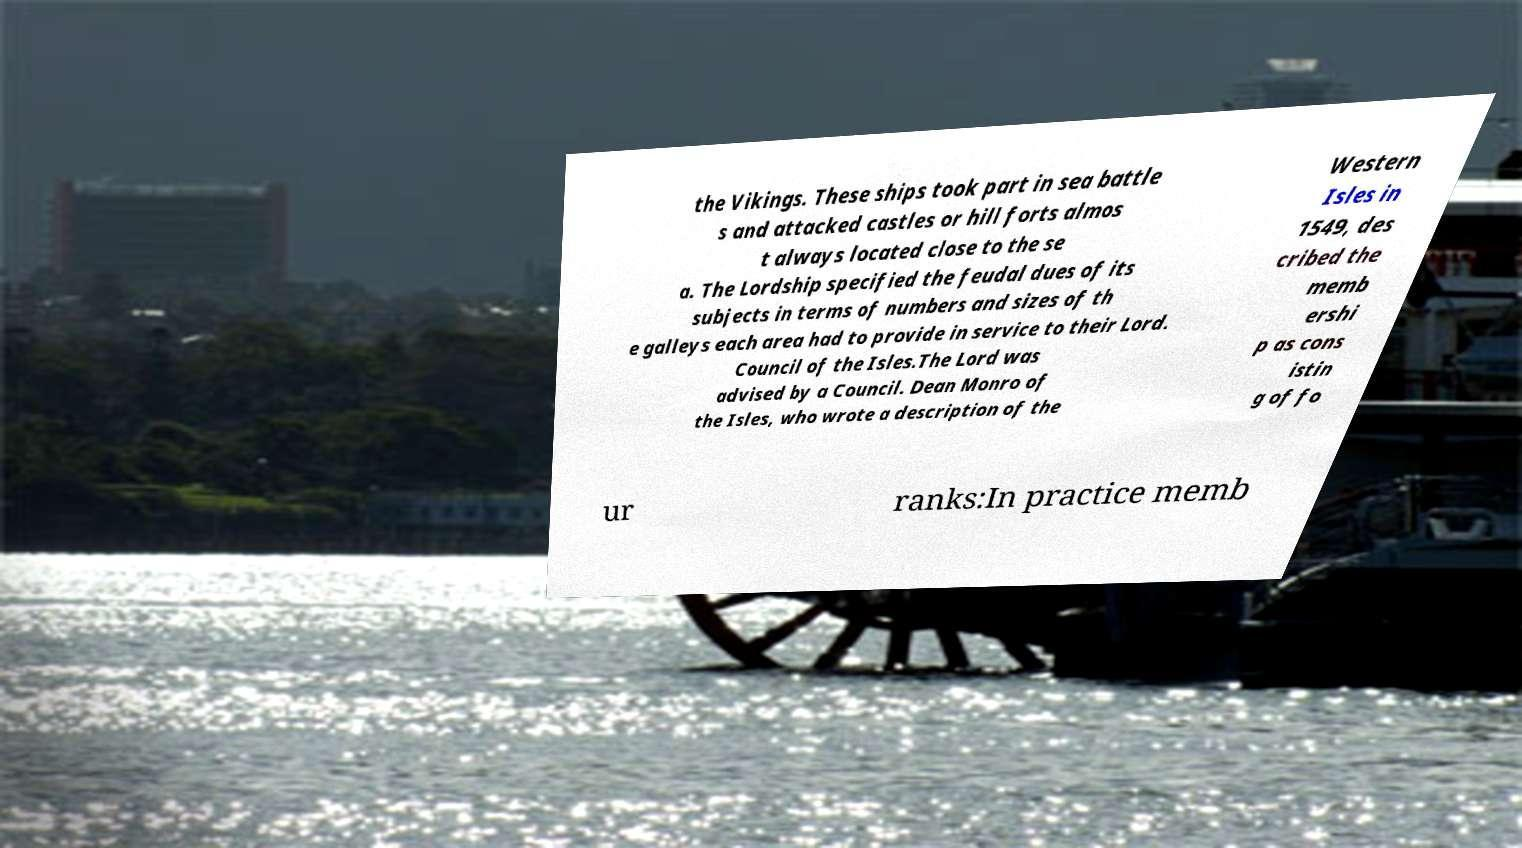There's text embedded in this image that I need extracted. Can you transcribe it verbatim? the Vikings. These ships took part in sea battle s and attacked castles or hill forts almos t always located close to the se a. The Lordship specified the feudal dues of its subjects in terms of numbers and sizes of th e galleys each area had to provide in service to their Lord. Council of the Isles.The Lord was advised by a Council. Dean Monro of the Isles, who wrote a description of the Western Isles in 1549, des cribed the memb ershi p as cons istin g of fo ur ranks:In practice memb 